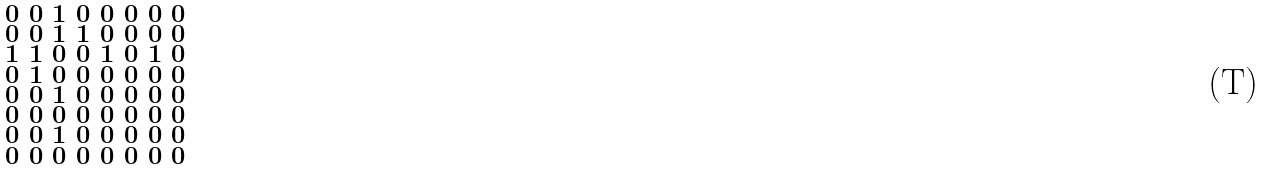<formula> <loc_0><loc_0><loc_500><loc_500>\begin{smallmatrix} 0 & 0 & 1 & 0 & 0 & 0 & 0 & 0 \\ 0 & 0 & 1 & 1 & 0 & 0 & 0 & 0 \\ 1 & 1 & 0 & 0 & 1 & 0 & 1 & 0 \\ 0 & 1 & 0 & 0 & 0 & 0 & 0 & 0 \\ 0 & 0 & 1 & 0 & 0 & 0 & 0 & 0 \\ 0 & 0 & 0 & 0 & 0 & 0 & 0 & 0 \\ 0 & 0 & 1 & 0 & 0 & 0 & 0 & 0 \\ 0 & 0 & 0 & 0 & 0 & 0 & 0 & 0 \end{smallmatrix}</formula> 